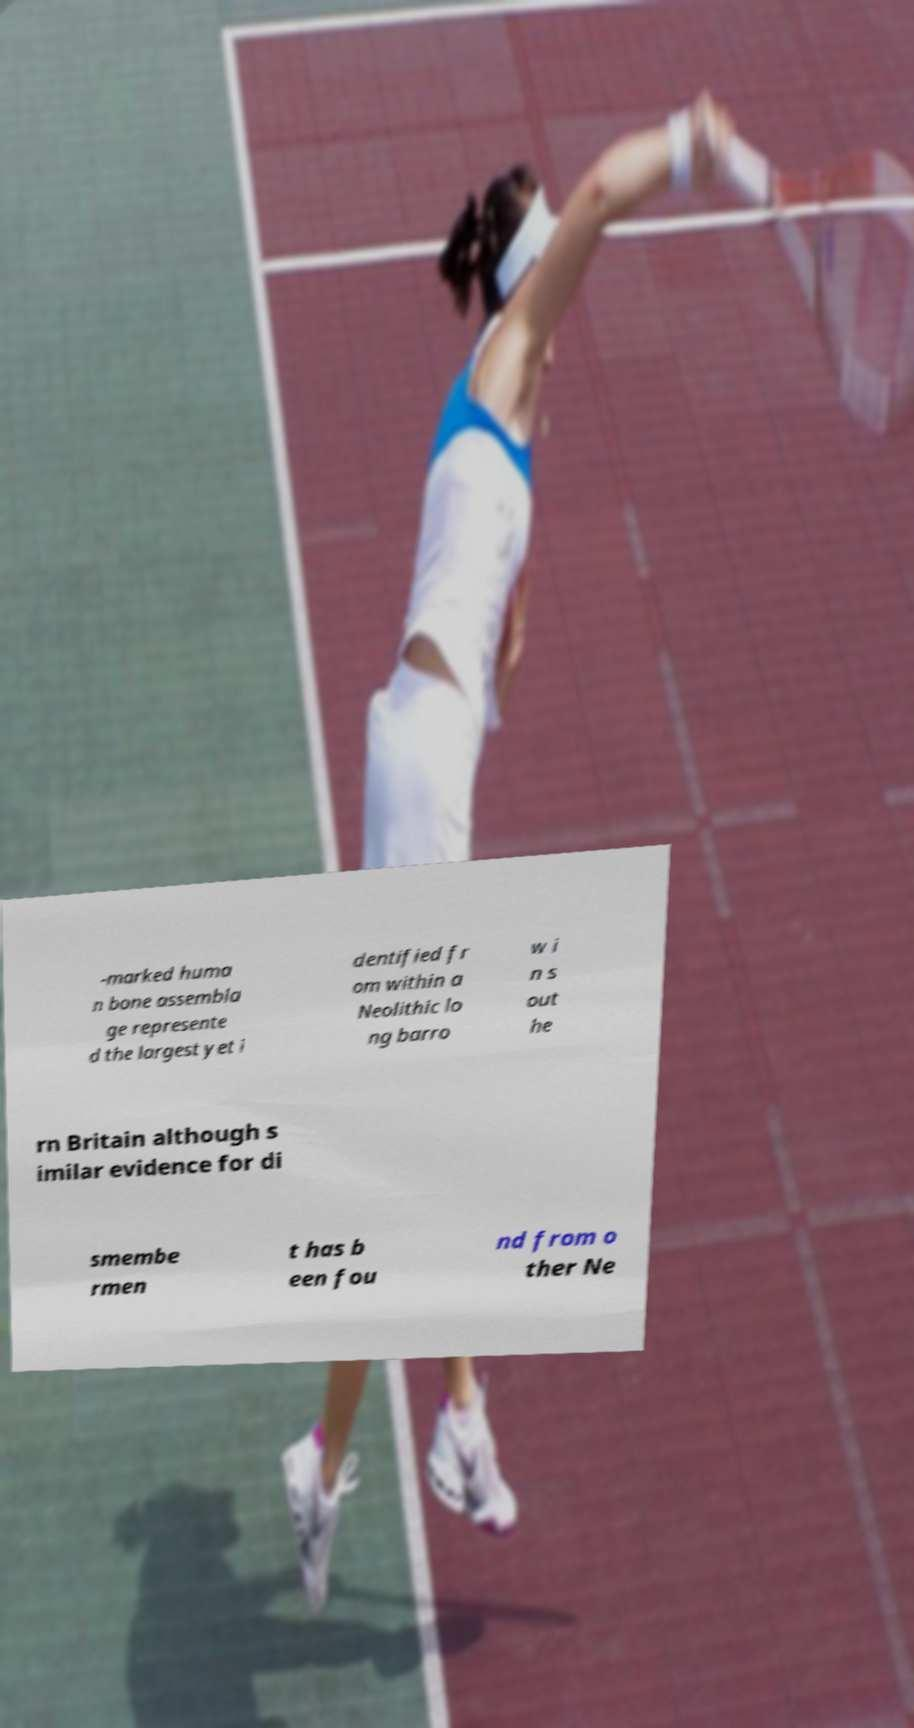There's text embedded in this image that I need extracted. Can you transcribe it verbatim? -marked huma n bone assembla ge represente d the largest yet i dentified fr om within a Neolithic lo ng barro w i n s out he rn Britain although s imilar evidence for di smembe rmen t has b een fou nd from o ther Ne 